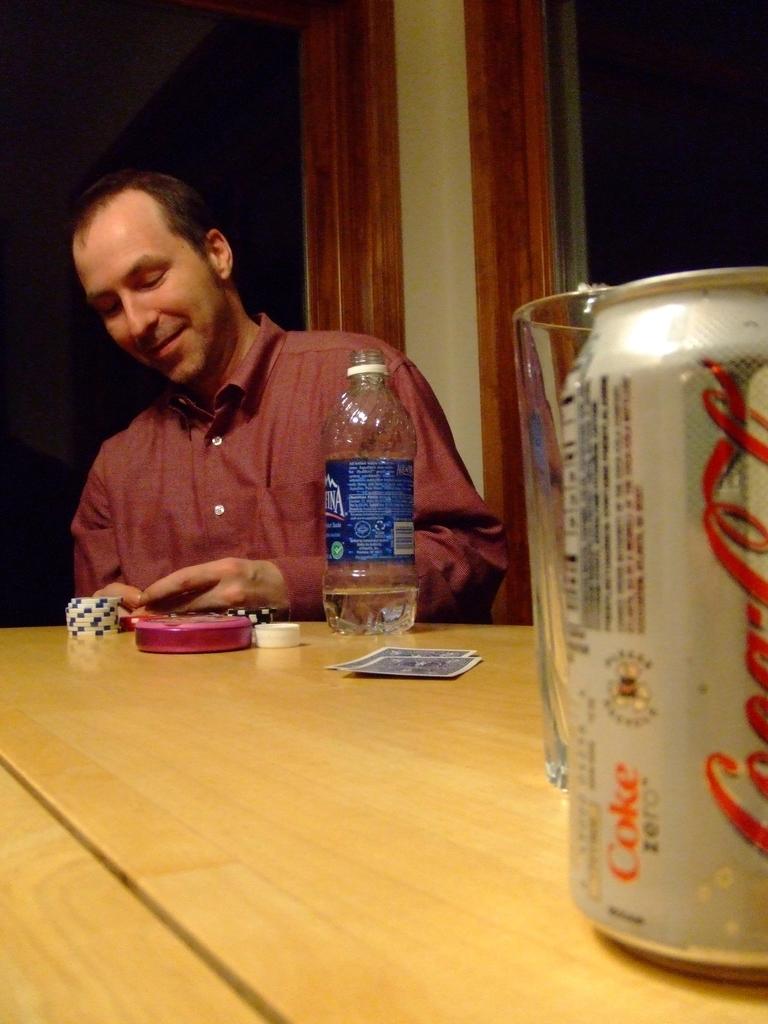Is that a can of coke zero?
Provide a succinct answer. Yes. What brand of water does it say?
Ensure brevity in your answer.  Aquafina. 